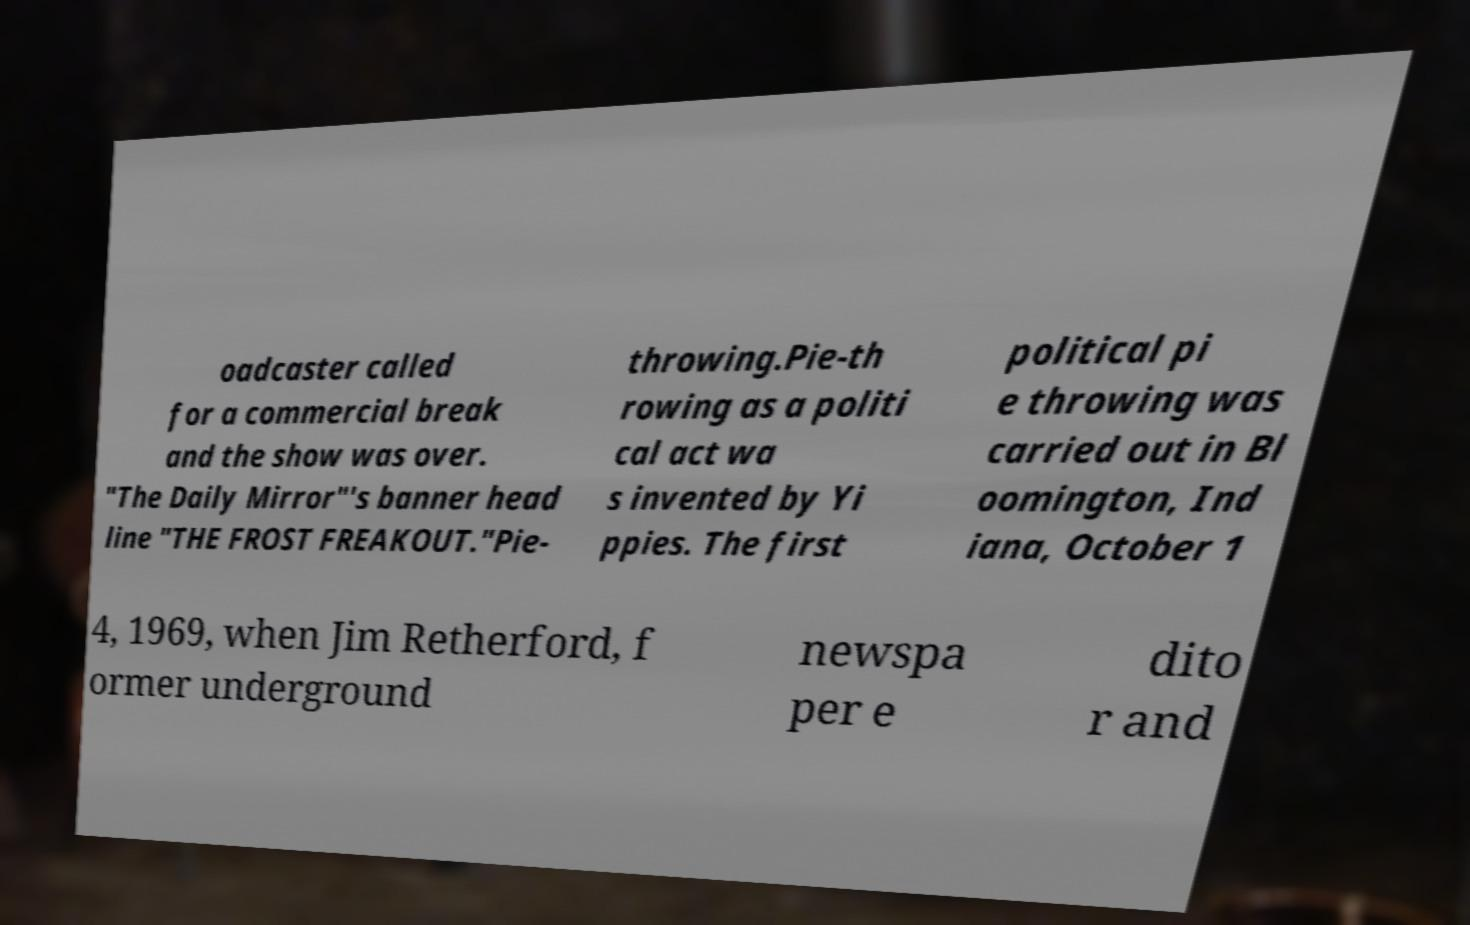Can you read and provide the text displayed in the image?This photo seems to have some interesting text. Can you extract and type it out for me? oadcaster called for a commercial break and the show was over. "The Daily Mirror"'s banner head line "THE FROST FREAKOUT."Pie- throwing.Pie-th rowing as a politi cal act wa s invented by Yi ppies. The first political pi e throwing was carried out in Bl oomington, Ind iana, October 1 4, 1969, when Jim Retherford, f ormer underground newspa per e dito r and 